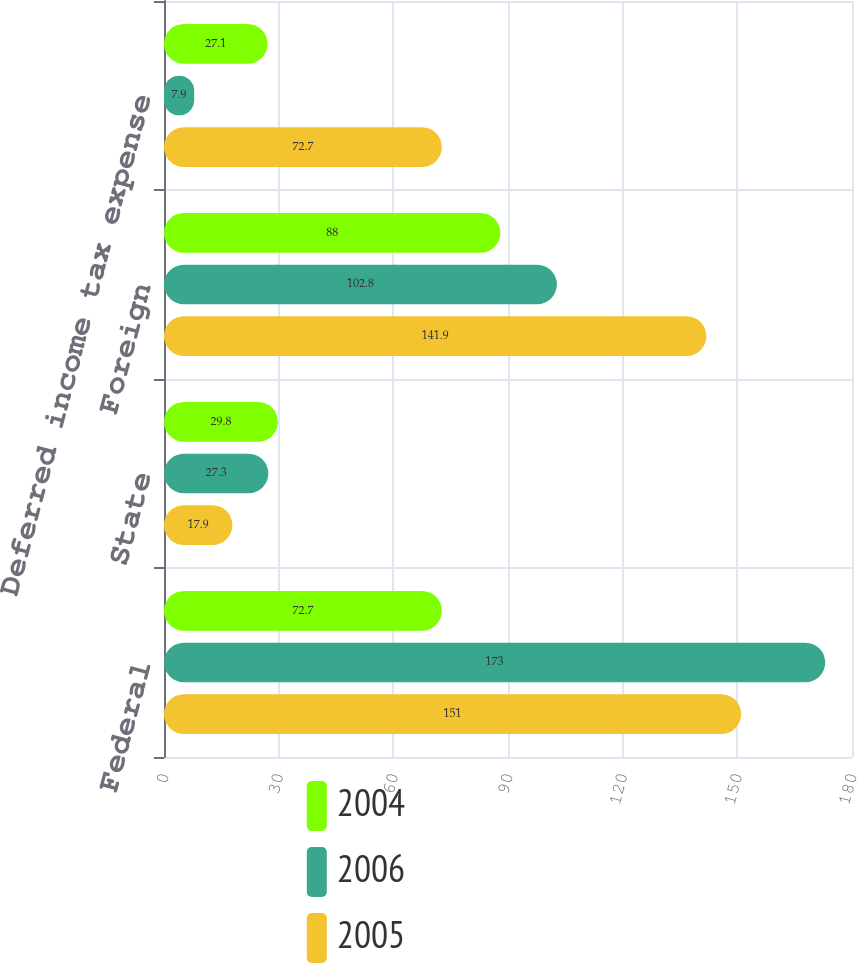Convert chart to OTSL. <chart><loc_0><loc_0><loc_500><loc_500><stacked_bar_chart><ecel><fcel>Federal<fcel>State<fcel>Foreign<fcel>Deferred income tax expense<nl><fcel>2004<fcel>72.7<fcel>29.8<fcel>88<fcel>27.1<nl><fcel>2006<fcel>173<fcel>27.3<fcel>102.8<fcel>7.9<nl><fcel>2005<fcel>151<fcel>17.9<fcel>141.9<fcel>72.7<nl></chart> 